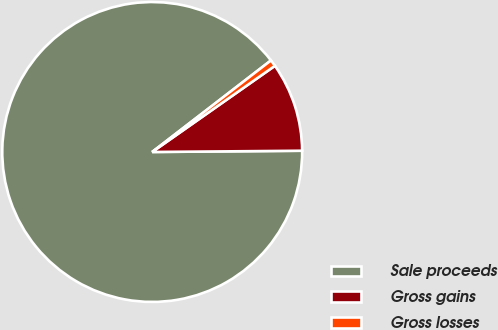<chart> <loc_0><loc_0><loc_500><loc_500><pie_chart><fcel>Sale proceeds<fcel>Gross gains<fcel>Gross losses<nl><fcel>89.68%<fcel>9.61%<fcel>0.71%<nl></chart> 